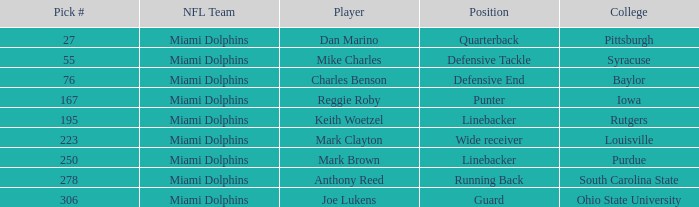For the running back position, what is the overall sum of pick #? 1.0. 